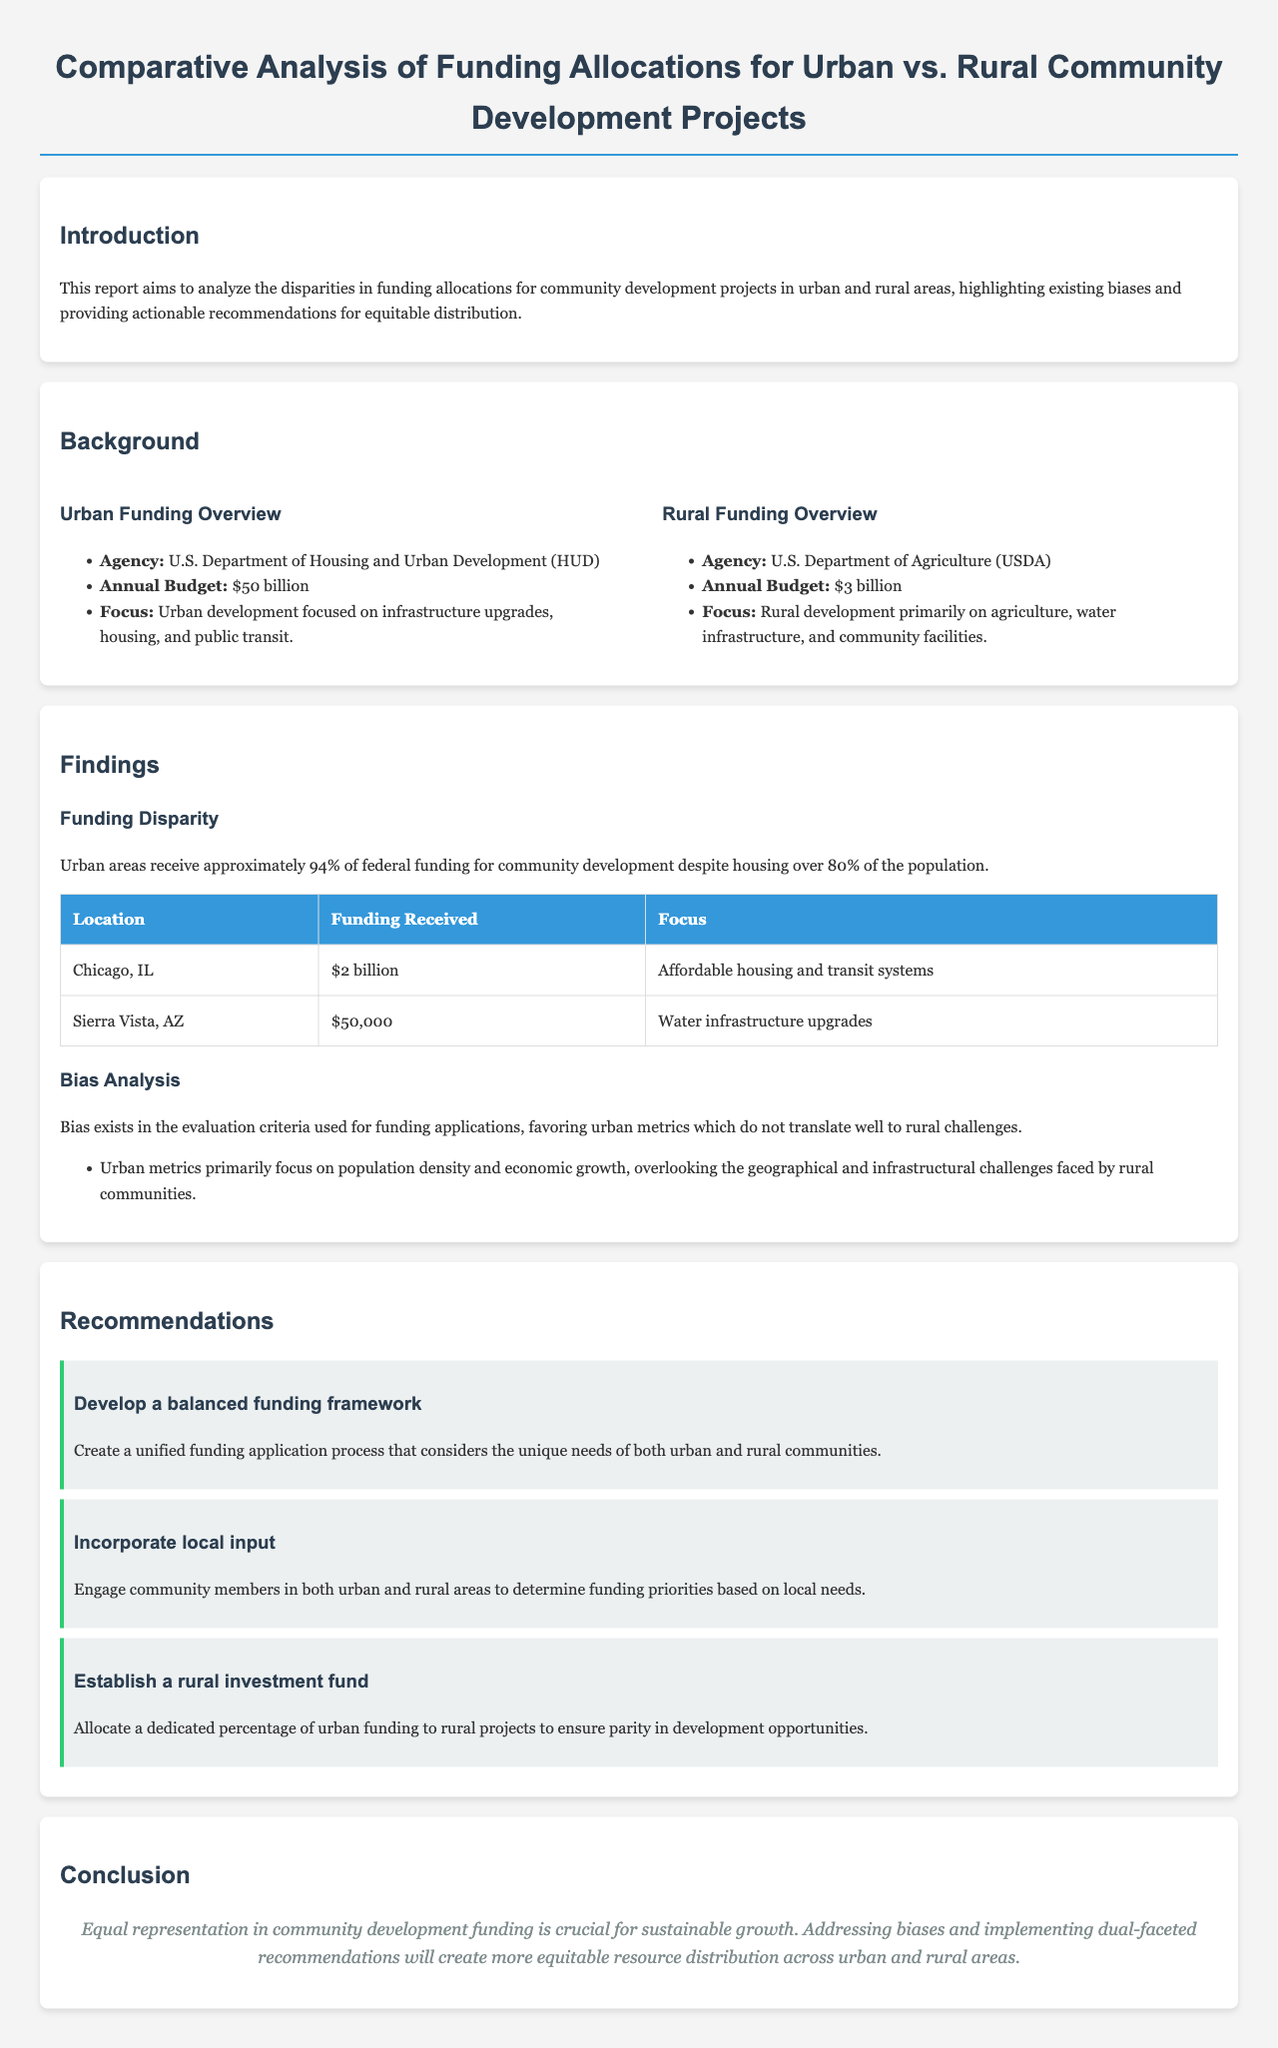What is the annual budget for urban development? The document states that the annual budget for urban development is dedicated to the U.S. Department of Housing and Urban Development, which is $50 billion.
Answer: $50 billion What agency is responsible for rural funding? According to the document, the agency responsible for rural funding is the U.S. Department of Agriculture.
Answer: U.S. Department of Agriculture What percentage of federal funding do urban areas receive? The report mentions that urban areas receive approximately 94% of federal funding for community development.
Answer: 94% What is the funding received by Chicago, IL? The document lists Chicago, IL with a funding amount of $2 billion for affordable housing and transit systems.
Answer: $2 billion What is one recommendation provided in the report? The report provides several recommendations, one being to develop a balanced funding framework for urban and rural communities.
Answer: Develop a balanced funding framework What major focus does rural funding primarily have? The document indicates that rural funding primarily focuses on agriculture, water infrastructure, and community facilities.
Answer: Agriculture, water infrastructure, and community facilities What unique criteria favor urban areas in funding evaluations? The bias analysis section highlights that urban metrics are focused on population density and economic growth, favoring evaluations for urban areas.
Answer: Population density and economic growth What is the conclusion about funding representation? The report concludes that equal representation in community development funding is crucial for sustainable growth.
Answer: Equal representation in community development funding is crucial for sustainable growth 